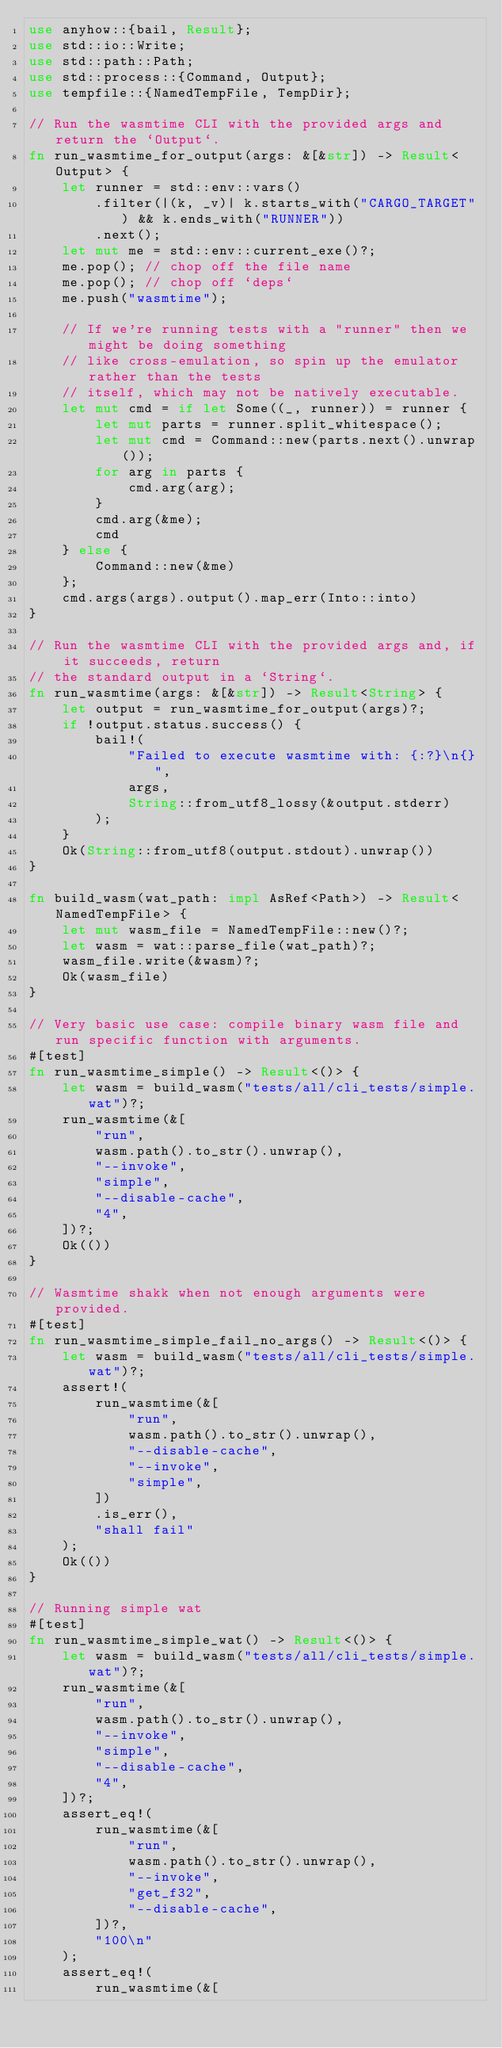<code> <loc_0><loc_0><loc_500><loc_500><_Rust_>use anyhow::{bail, Result};
use std::io::Write;
use std::path::Path;
use std::process::{Command, Output};
use tempfile::{NamedTempFile, TempDir};

// Run the wasmtime CLI with the provided args and return the `Output`.
fn run_wasmtime_for_output(args: &[&str]) -> Result<Output> {
    let runner = std::env::vars()
        .filter(|(k, _v)| k.starts_with("CARGO_TARGET") && k.ends_with("RUNNER"))
        .next();
    let mut me = std::env::current_exe()?;
    me.pop(); // chop off the file name
    me.pop(); // chop off `deps`
    me.push("wasmtime");

    // If we're running tests with a "runner" then we might be doing something
    // like cross-emulation, so spin up the emulator rather than the tests
    // itself, which may not be natively executable.
    let mut cmd = if let Some((_, runner)) = runner {
        let mut parts = runner.split_whitespace();
        let mut cmd = Command::new(parts.next().unwrap());
        for arg in parts {
            cmd.arg(arg);
        }
        cmd.arg(&me);
        cmd
    } else {
        Command::new(&me)
    };
    cmd.args(args).output().map_err(Into::into)
}

// Run the wasmtime CLI with the provided args and, if it succeeds, return
// the standard output in a `String`.
fn run_wasmtime(args: &[&str]) -> Result<String> {
    let output = run_wasmtime_for_output(args)?;
    if !output.status.success() {
        bail!(
            "Failed to execute wasmtime with: {:?}\n{}",
            args,
            String::from_utf8_lossy(&output.stderr)
        );
    }
    Ok(String::from_utf8(output.stdout).unwrap())
}

fn build_wasm(wat_path: impl AsRef<Path>) -> Result<NamedTempFile> {
    let mut wasm_file = NamedTempFile::new()?;
    let wasm = wat::parse_file(wat_path)?;
    wasm_file.write(&wasm)?;
    Ok(wasm_file)
}

// Very basic use case: compile binary wasm file and run specific function with arguments.
#[test]
fn run_wasmtime_simple() -> Result<()> {
    let wasm = build_wasm("tests/all/cli_tests/simple.wat")?;
    run_wasmtime(&[
        "run",
        wasm.path().to_str().unwrap(),
        "--invoke",
        "simple",
        "--disable-cache",
        "4",
    ])?;
    Ok(())
}

// Wasmtime shakk when not enough arguments were provided.
#[test]
fn run_wasmtime_simple_fail_no_args() -> Result<()> {
    let wasm = build_wasm("tests/all/cli_tests/simple.wat")?;
    assert!(
        run_wasmtime(&[
            "run",
            wasm.path().to_str().unwrap(),
            "--disable-cache",
            "--invoke",
            "simple",
        ])
        .is_err(),
        "shall fail"
    );
    Ok(())
}

// Running simple wat
#[test]
fn run_wasmtime_simple_wat() -> Result<()> {
    let wasm = build_wasm("tests/all/cli_tests/simple.wat")?;
    run_wasmtime(&[
        "run",
        wasm.path().to_str().unwrap(),
        "--invoke",
        "simple",
        "--disable-cache",
        "4",
    ])?;
    assert_eq!(
        run_wasmtime(&[
            "run",
            wasm.path().to_str().unwrap(),
            "--invoke",
            "get_f32",
            "--disable-cache",
        ])?,
        "100\n"
    );
    assert_eq!(
        run_wasmtime(&[</code> 